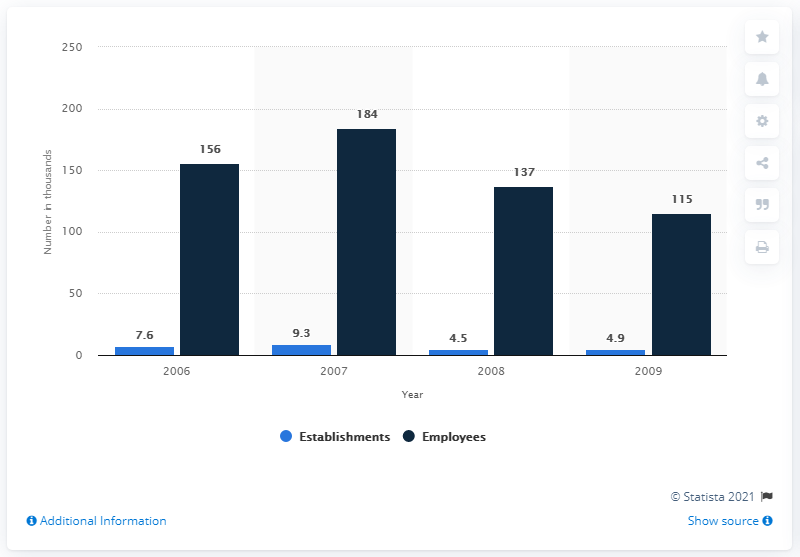Identify some key points in this picture. The highest value of employees is 69. The information regarding the number of establishments and employees in the investment banking business in the US has been available for approximately 4 years. 